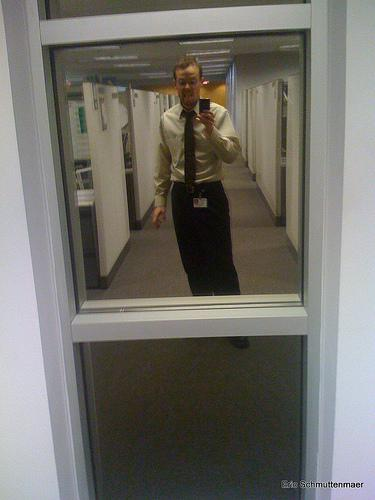Question: what is the man in the picture doing?
Choices:
A. Running.
B. Taking a picture of himself.
C. Jumping.
D. Eating.
Answer with the letter. Answer: B Question: where is the man located?
Choices:
A. In the kitchen.
B. In an office.
C. In the bedroom.
D. In the bathroom.
Answer with the letter. Answer: B Question: what does the man have around his neck?
Choices:
A. An ascot.
B. A tie.
C. A bolero.
D. A scarf.
Answer with the letter. Answer: B Question: where in the office is the man standing?
Choices:
A. Behind a desk.
B. At reception.
C. In the hallway between cubicles.
D. Near the break room.
Answer with the letter. Answer: C Question: what does the man have clipped to his belt?
Choices:
A. A money clip.
B. A cell phone.
C. His wallet.
D. An ID card.
Answer with the letter. Answer: D 